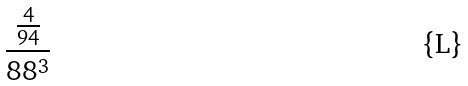<formula> <loc_0><loc_0><loc_500><loc_500>\frac { \frac { 4 } { 9 4 } } { 8 8 ^ { 3 } }</formula> 